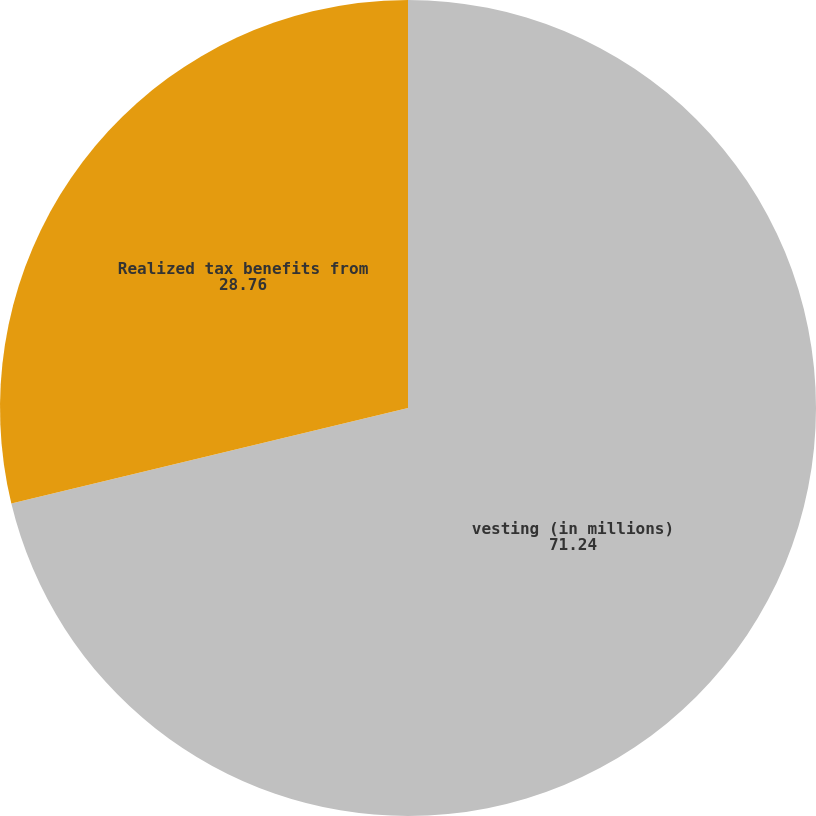<chart> <loc_0><loc_0><loc_500><loc_500><pie_chart><fcel>vesting (in millions)<fcel>Realized tax benefits from<nl><fcel>71.24%<fcel>28.76%<nl></chart> 